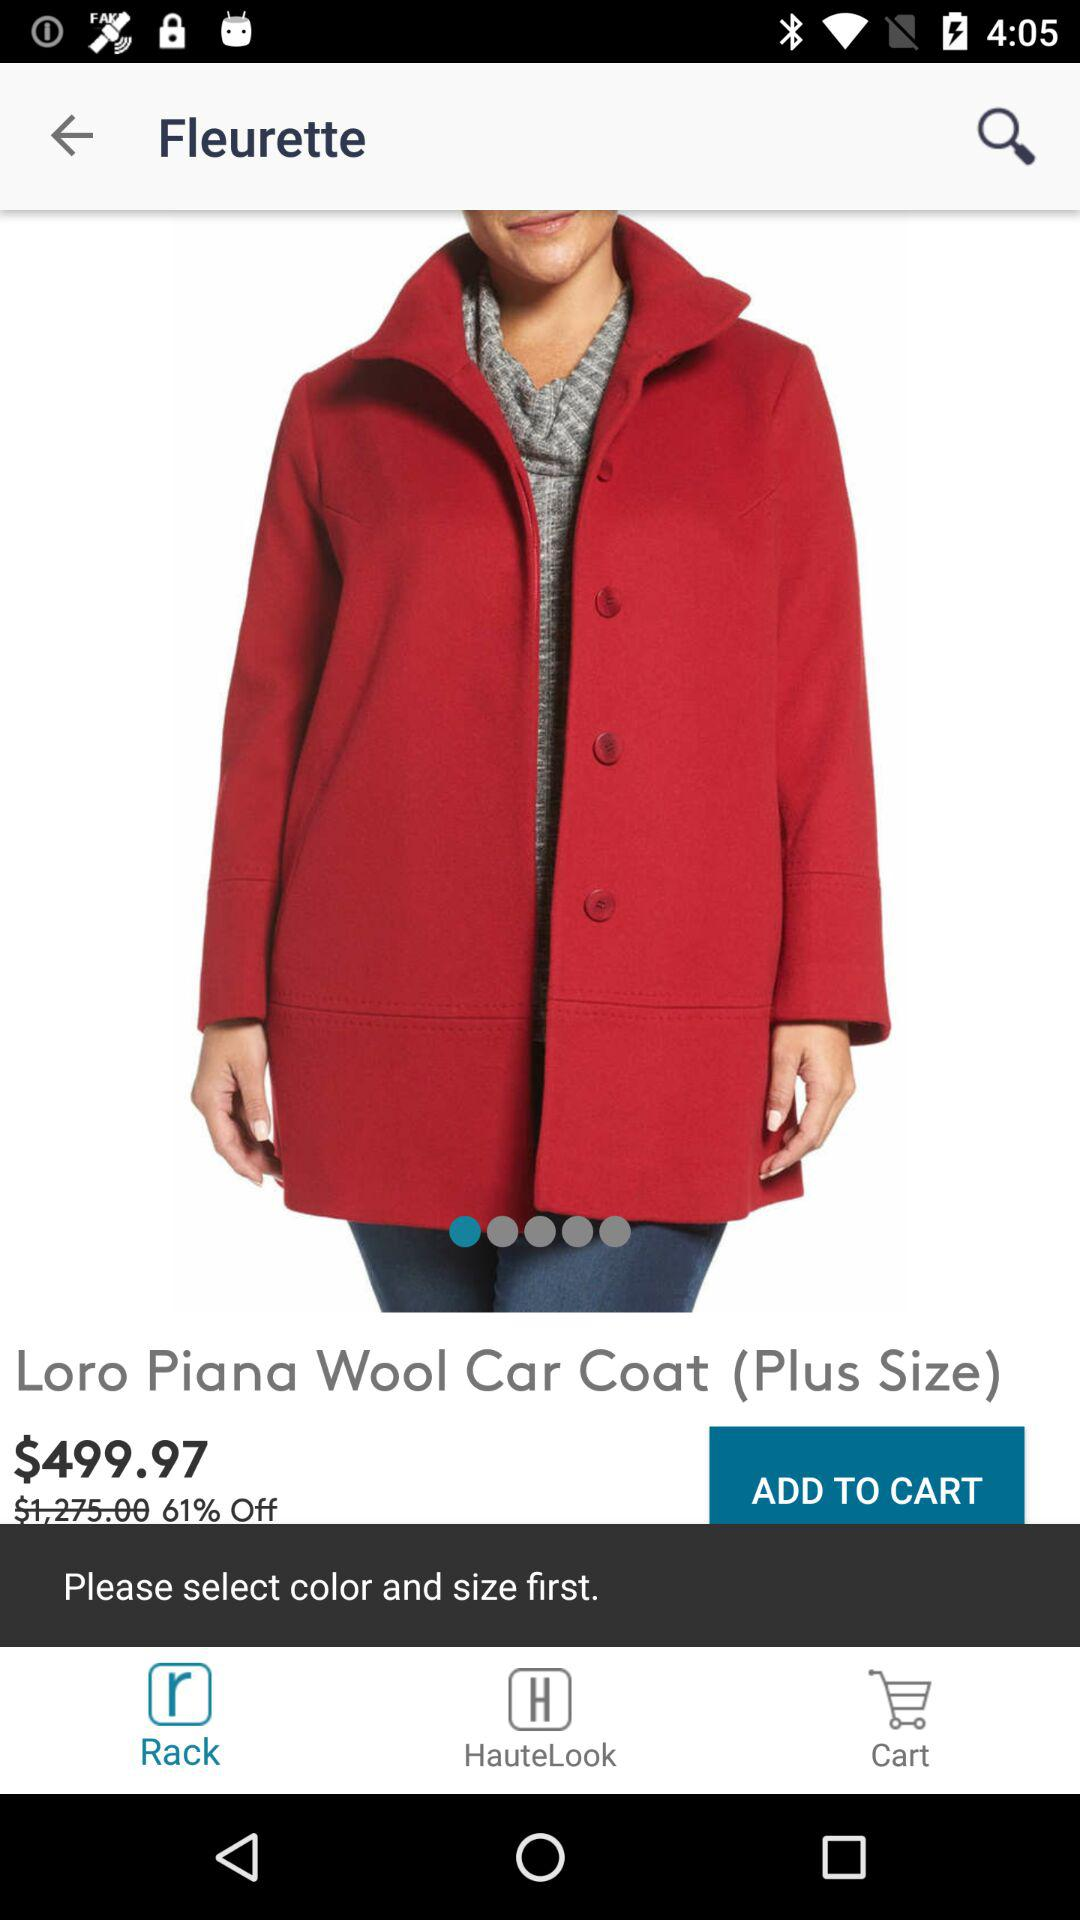What is the item name? The item name is "Loro Piana Wool Car Coat". 